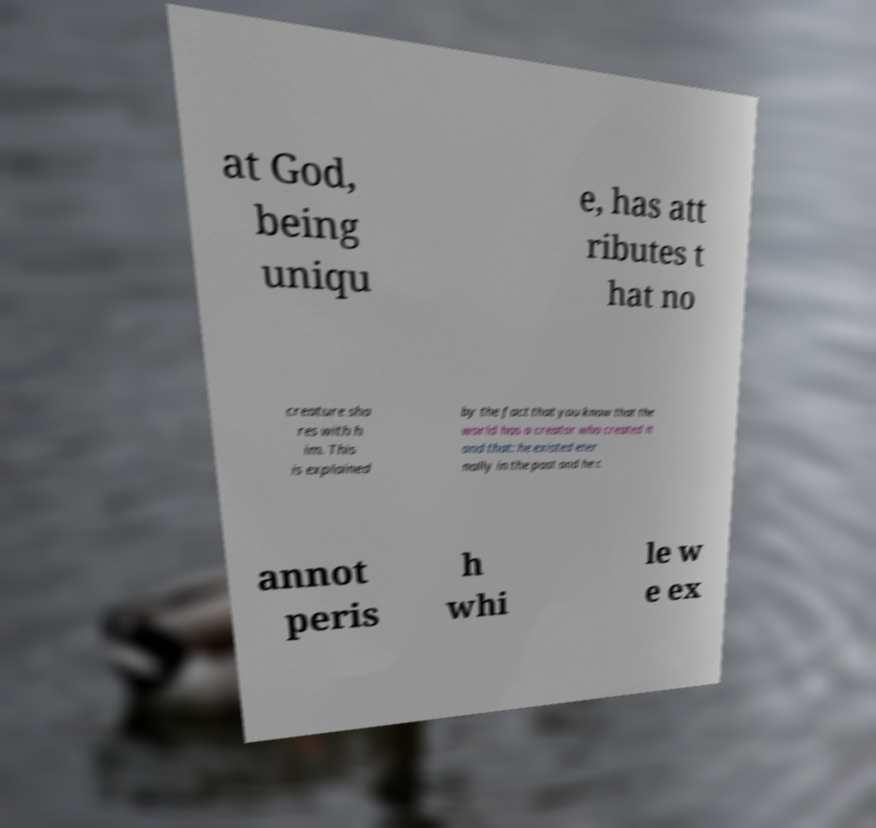Can you accurately transcribe the text from the provided image for me? at God, being uniqu e, has att ributes t hat no creature sha res with h im. This is explained by the fact that you know that the world has a creator who created it and that: he existed eter nally in the past and he c annot peris h whi le w e ex 